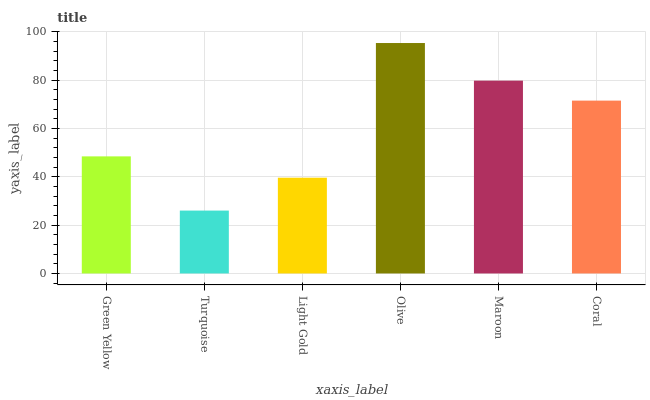Is Turquoise the minimum?
Answer yes or no. Yes. Is Olive the maximum?
Answer yes or no. Yes. Is Light Gold the minimum?
Answer yes or no. No. Is Light Gold the maximum?
Answer yes or no. No. Is Light Gold greater than Turquoise?
Answer yes or no. Yes. Is Turquoise less than Light Gold?
Answer yes or no. Yes. Is Turquoise greater than Light Gold?
Answer yes or no. No. Is Light Gold less than Turquoise?
Answer yes or no. No. Is Coral the high median?
Answer yes or no. Yes. Is Green Yellow the low median?
Answer yes or no. Yes. Is Olive the high median?
Answer yes or no. No. Is Turquoise the low median?
Answer yes or no. No. 